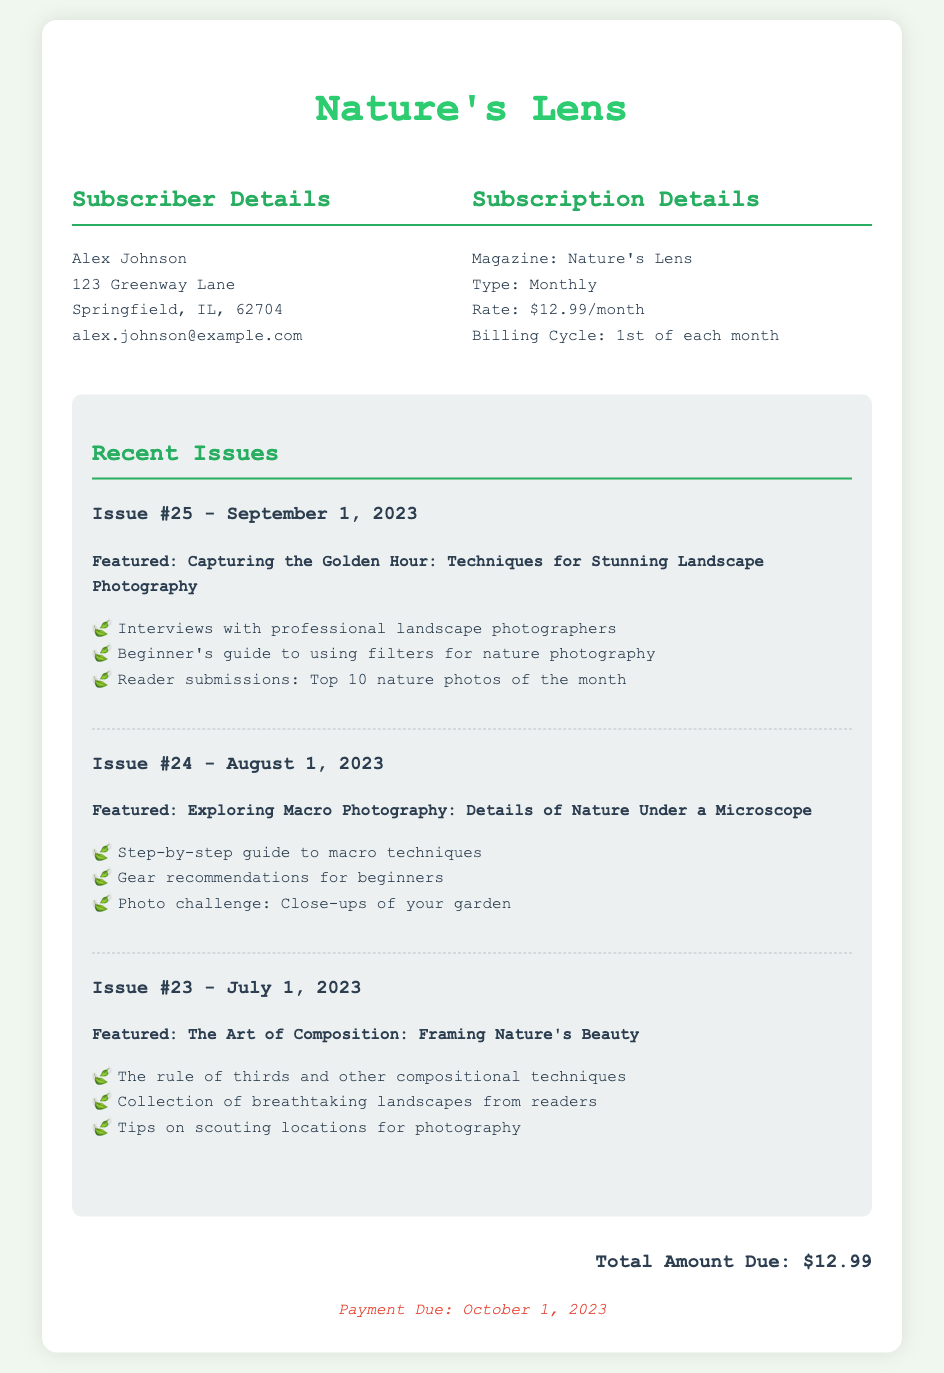What is the subscriber's name? The subscriber's name is provided in the details section of the document.
Answer: Alex Johnson What is the monthly subscription rate? The document specifies the monthly subscription rate in the subscription details.
Answer: $12.99/month What is the payment due date? The due date for the payment is clearly mentioned at the end of the document.
Answer: October 1, 2023 How many past issues are listed? The document contains three past issues listed under the recent issues section.
Answer: 3 What is the featured topic of Issue #25? The featured topic of Issue #25 is outlined in the recent issues section.
Answer: Capturing the Golden Hour: Techniques for Stunning Landscape Photography What is the total amount due? The total amount due is located in the final section of the document.
Answer: $12.99 What is the magazine's name? The magazine's name can be found at the top of the document.
Answer: Nature's Lens Which issue featured macro photography? The specific issue that focused on macro photography is listed in the recent issues section.
Answer: Issue #24 What is the billing cycle? The billing cycle is specified in the subscription details.
Answer: 1st of each month 